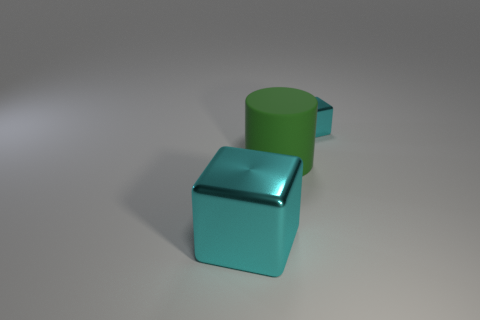Add 2 cyan shiny things. How many objects exist? 5 Subtract all cubes. How many objects are left? 1 Add 3 large green matte cylinders. How many large green matte cylinders exist? 4 Subtract 1 cyan blocks. How many objects are left? 2 Subtract all large cyan things. Subtract all large cyan things. How many objects are left? 1 Add 1 cyan metallic blocks. How many cyan metallic blocks are left? 3 